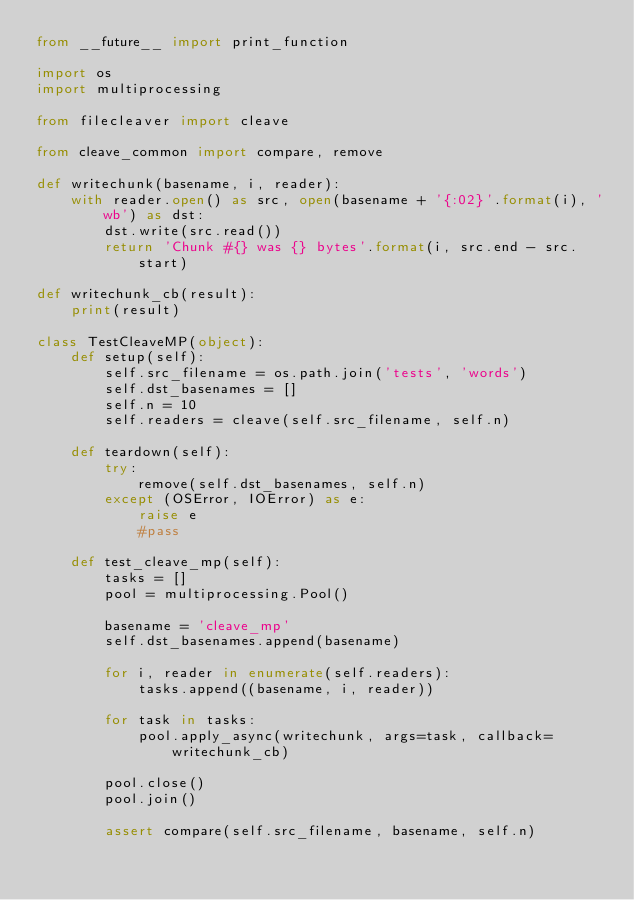<code> <loc_0><loc_0><loc_500><loc_500><_Python_>from __future__ import print_function

import os
import multiprocessing

from filecleaver import cleave

from cleave_common import compare, remove

def writechunk(basename, i, reader):
    with reader.open() as src, open(basename + '{:02}'.format(i), 'wb') as dst:
        dst.write(src.read())
        return 'Chunk #{} was {} bytes'.format(i, src.end - src.start)

def writechunk_cb(result):
    print(result)

class TestCleaveMP(object):
    def setup(self):
        self.src_filename = os.path.join('tests', 'words')
        self.dst_basenames = []
        self.n = 10
        self.readers = cleave(self.src_filename, self.n)

    def teardown(self):
        try:
            remove(self.dst_basenames, self.n)
        except (OSError, IOError) as e:
            raise e
            #pass

    def test_cleave_mp(self):
        tasks = []
        pool = multiprocessing.Pool()

        basename = 'cleave_mp'
        self.dst_basenames.append(basename)

        for i, reader in enumerate(self.readers):
            tasks.append((basename, i, reader))

        for task in tasks:
            pool.apply_async(writechunk, args=task, callback=writechunk_cb)

        pool.close()
        pool.join()

        assert compare(self.src_filename, basename, self.n)

</code> 